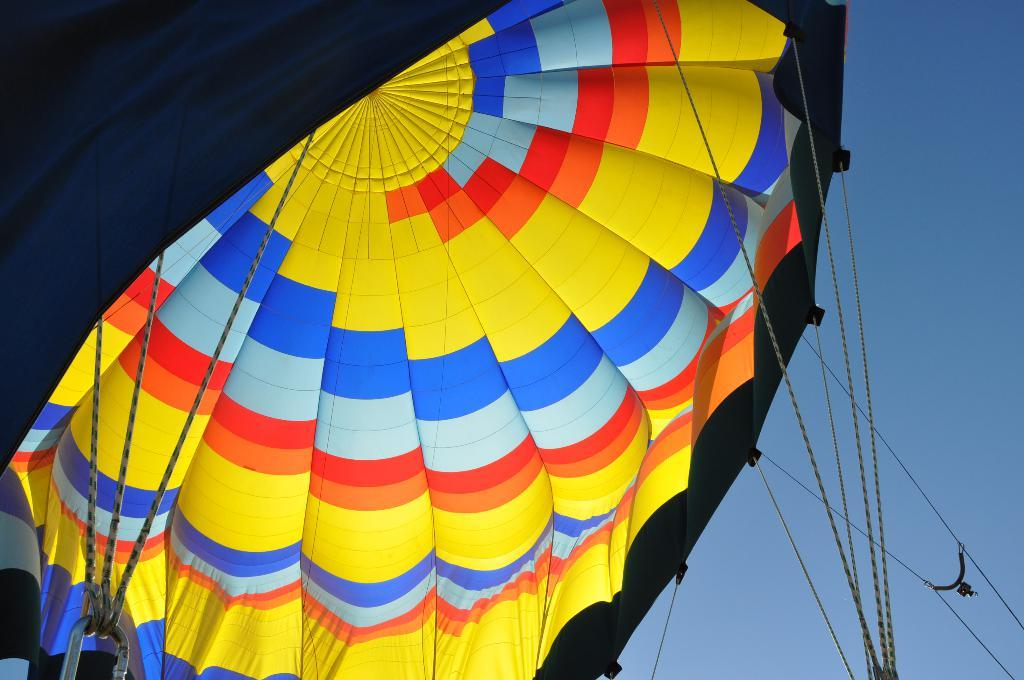What activity is depicted in the image? There is a Paragliding in the image. How is the Paragliding secured in the image? The Paragliding is tied with ropes. What is the ropes connected to besides the Paragliding? The ropes are connected to a metal object. Can you describe the connection between the ropes and the sky? The ropes are also connected to the sky, suggesting that the Paragliding is in flight. What type of toys can be seen playing basketball in the image? There are no toys or basketball present in the image; it features a Paragliding tied with ropes and connected to a metal object and the sky. 